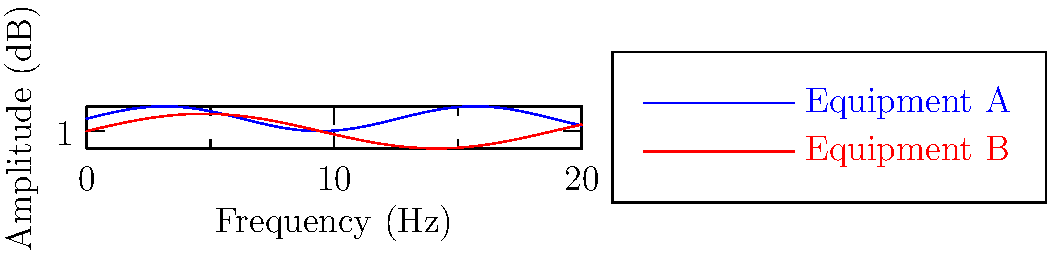Analyzing the frequency response curves of two high-end audio equipment pieces, which one would provide a flatter response in the mid-range frequencies (around 1 kHz to 5 kHz), potentially offering a more neutral sound signature that Frankie Goes to Hollywood's complex layered productions would benefit from? To determine which equipment provides a flatter response in the mid-range frequencies, we need to analyze the curves:

1. The blue curve represents Equipment A, while the red curve represents Equipment B.

2. Mid-range frequencies (1 kHz to 5 kHz) are crucial for vocal clarity and instrument separation, which is essential for Frankie Goes to Hollywood's layered sound.

3. Observe the curves in the middle section of the graph:
   - Equipment A (blue) shows more pronounced peaks and dips.
   - Equipment B (red) has a smoother, more consistent curve.

4. A flatter response means less coloration of the sound, which is desirable for accurately reproducing complex mixes.

5. Equipment B's curve is closer to a straight line in the mid-range, indicating a more neutral frequency response.

6. This flatter response of Equipment B would better preserve the intricate layers and details in Frankie Goes to Hollywood's music without over-emphasizing or under-representing certain frequencies.

Therefore, Equipment B would provide a flatter response in the mid-range frequencies, offering a more neutral sound signature that would benefit Frankie Goes to Hollywood's complex productions.
Answer: Equipment B 